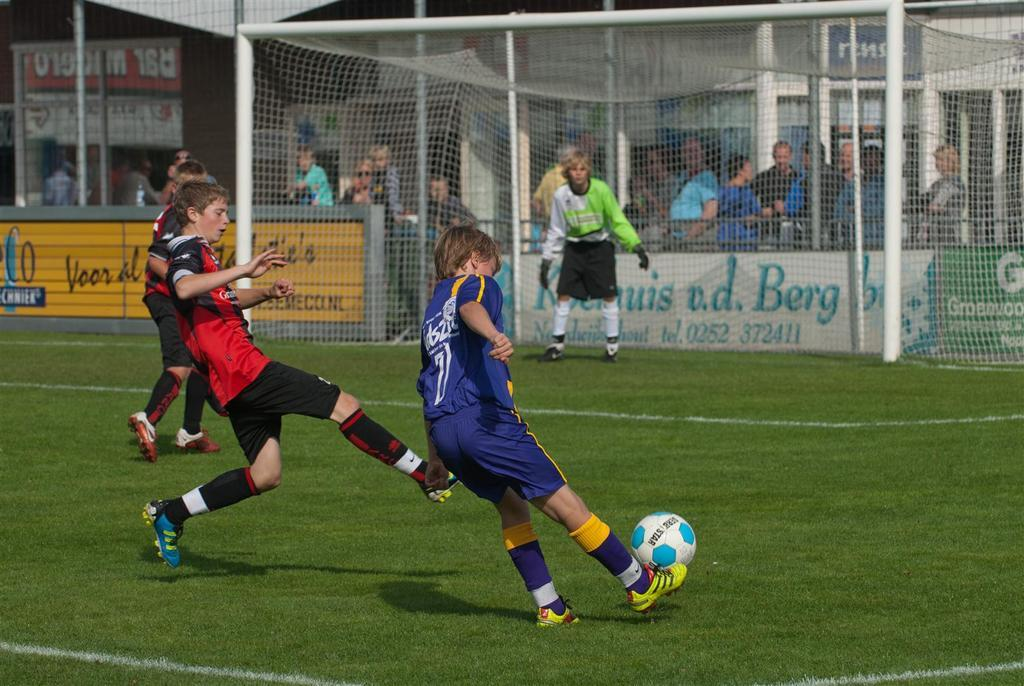<image>
Write a terse but informative summary of the picture. Player number 7 kicks the ball towards a sign that says " v.d. Berg" 